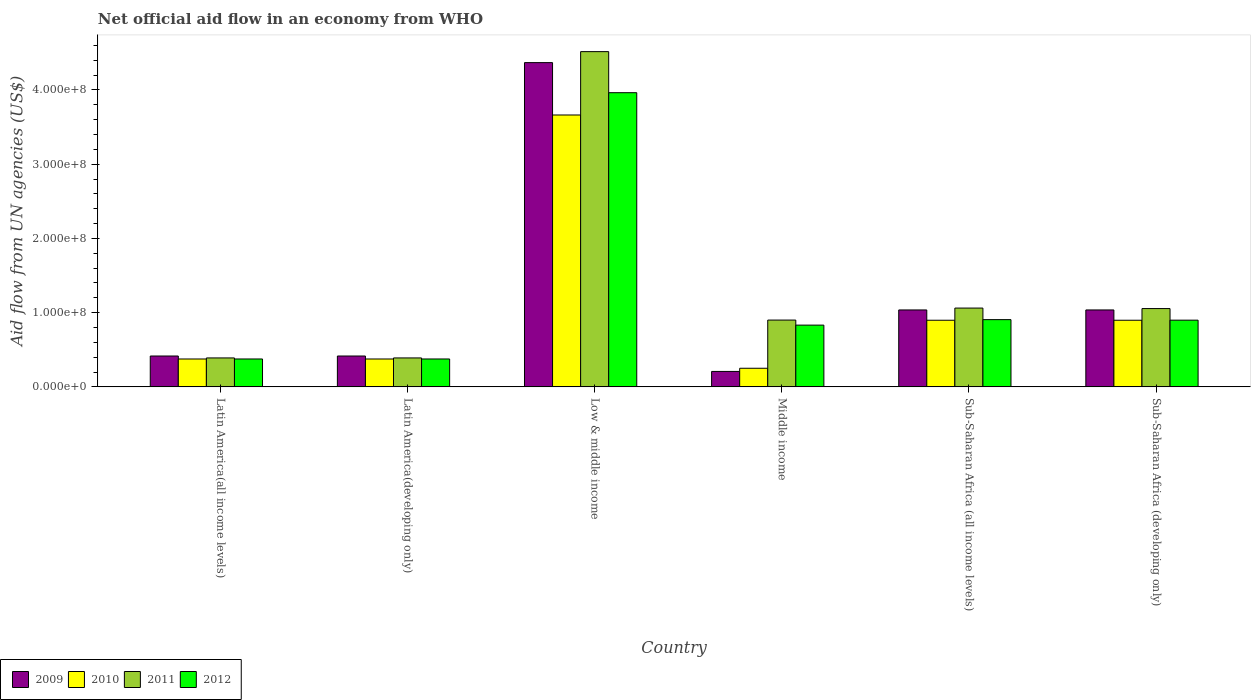How many different coloured bars are there?
Your answer should be very brief. 4. How many groups of bars are there?
Make the answer very short. 6. Are the number of bars per tick equal to the number of legend labels?
Keep it short and to the point. Yes. What is the label of the 2nd group of bars from the left?
Your response must be concise. Latin America(developing only). What is the net official aid flow in 2009 in Latin America(developing only)?
Your response must be concise. 4.16e+07. Across all countries, what is the maximum net official aid flow in 2011?
Your answer should be very brief. 4.52e+08. Across all countries, what is the minimum net official aid flow in 2009?
Your answer should be compact. 2.08e+07. In which country was the net official aid flow in 2009 maximum?
Provide a succinct answer. Low & middle income. In which country was the net official aid flow in 2009 minimum?
Provide a short and direct response. Middle income. What is the total net official aid flow in 2011 in the graph?
Make the answer very short. 8.31e+08. What is the difference between the net official aid flow in 2012 in Latin America(developing only) and that in Low & middle income?
Your answer should be very brief. -3.59e+08. What is the difference between the net official aid flow in 2012 in Low & middle income and the net official aid flow in 2011 in Sub-Saharan Africa (all income levels)?
Offer a terse response. 2.90e+08. What is the average net official aid flow in 2010 per country?
Offer a very short reply. 1.08e+08. What is the difference between the net official aid flow of/in 2009 and net official aid flow of/in 2010 in Sub-Saharan Africa (all income levels)?
Provide a short and direct response. 1.39e+07. What is the ratio of the net official aid flow in 2010 in Middle income to that in Sub-Saharan Africa (developing only)?
Ensure brevity in your answer.  0.28. Is the difference between the net official aid flow in 2009 in Latin America(developing only) and Sub-Saharan Africa (all income levels) greater than the difference between the net official aid flow in 2010 in Latin America(developing only) and Sub-Saharan Africa (all income levels)?
Offer a terse response. No. What is the difference between the highest and the second highest net official aid flow in 2012?
Ensure brevity in your answer.  3.06e+08. What is the difference between the highest and the lowest net official aid flow in 2012?
Keep it short and to the point. 3.59e+08. In how many countries, is the net official aid flow in 2010 greater than the average net official aid flow in 2010 taken over all countries?
Your response must be concise. 1. Is the sum of the net official aid flow in 2009 in Sub-Saharan Africa (all income levels) and Sub-Saharan Africa (developing only) greater than the maximum net official aid flow in 2010 across all countries?
Offer a very short reply. No. Is it the case that in every country, the sum of the net official aid flow in 2010 and net official aid flow in 2009 is greater than the sum of net official aid flow in 2011 and net official aid flow in 2012?
Offer a very short reply. No. What does the 1st bar from the right in Middle income represents?
Keep it short and to the point. 2012. Is it the case that in every country, the sum of the net official aid flow in 2012 and net official aid flow in 2009 is greater than the net official aid flow in 2011?
Keep it short and to the point. Yes. How many bars are there?
Give a very brief answer. 24. Are all the bars in the graph horizontal?
Your answer should be very brief. No. How many countries are there in the graph?
Offer a terse response. 6. What is the difference between two consecutive major ticks on the Y-axis?
Give a very brief answer. 1.00e+08. Does the graph contain any zero values?
Ensure brevity in your answer.  No. Does the graph contain grids?
Your answer should be compact. No. How are the legend labels stacked?
Your response must be concise. Horizontal. What is the title of the graph?
Ensure brevity in your answer.  Net official aid flow in an economy from WHO. Does "1966" appear as one of the legend labels in the graph?
Your answer should be very brief. No. What is the label or title of the Y-axis?
Offer a very short reply. Aid flow from UN agencies (US$). What is the Aid flow from UN agencies (US$) of 2009 in Latin America(all income levels)?
Your answer should be very brief. 4.16e+07. What is the Aid flow from UN agencies (US$) of 2010 in Latin America(all income levels)?
Provide a short and direct response. 3.76e+07. What is the Aid flow from UN agencies (US$) in 2011 in Latin America(all income levels)?
Offer a very short reply. 3.90e+07. What is the Aid flow from UN agencies (US$) of 2012 in Latin America(all income levels)?
Provide a succinct answer. 3.76e+07. What is the Aid flow from UN agencies (US$) of 2009 in Latin America(developing only)?
Your response must be concise. 4.16e+07. What is the Aid flow from UN agencies (US$) of 2010 in Latin America(developing only)?
Give a very brief answer. 3.76e+07. What is the Aid flow from UN agencies (US$) in 2011 in Latin America(developing only)?
Provide a short and direct response. 3.90e+07. What is the Aid flow from UN agencies (US$) of 2012 in Latin America(developing only)?
Offer a very short reply. 3.76e+07. What is the Aid flow from UN agencies (US$) in 2009 in Low & middle income?
Ensure brevity in your answer.  4.37e+08. What is the Aid flow from UN agencies (US$) of 2010 in Low & middle income?
Keep it short and to the point. 3.66e+08. What is the Aid flow from UN agencies (US$) in 2011 in Low & middle income?
Your response must be concise. 4.52e+08. What is the Aid flow from UN agencies (US$) in 2012 in Low & middle income?
Keep it short and to the point. 3.96e+08. What is the Aid flow from UN agencies (US$) of 2009 in Middle income?
Keep it short and to the point. 2.08e+07. What is the Aid flow from UN agencies (US$) of 2010 in Middle income?
Your answer should be compact. 2.51e+07. What is the Aid flow from UN agencies (US$) in 2011 in Middle income?
Offer a very short reply. 9.00e+07. What is the Aid flow from UN agencies (US$) of 2012 in Middle income?
Your answer should be compact. 8.32e+07. What is the Aid flow from UN agencies (US$) in 2009 in Sub-Saharan Africa (all income levels)?
Ensure brevity in your answer.  1.04e+08. What is the Aid flow from UN agencies (US$) of 2010 in Sub-Saharan Africa (all income levels)?
Your answer should be compact. 8.98e+07. What is the Aid flow from UN agencies (US$) of 2011 in Sub-Saharan Africa (all income levels)?
Offer a terse response. 1.06e+08. What is the Aid flow from UN agencies (US$) of 2012 in Sub-Saharan Africa (all income levels)?
Ensure brevity in your answer.  9.06e+07. What is the Aid flow from UN agencies (US$) in 2009 in Sub-Saharan Africa (developing only)?
Your answer should be compact. 1.04e+08. What is the Aid flow from UN agencies (US$) in 2010 in Sub-Saharan Africa (developing only)?
Your answer should be compact. 8.98e+07. What is the Aid flow from UN agencies (US$) of 2011 in Sub-Saharan Africa (developing only)?
Offer a terse response. 1.05e+08. What is the Aid flow from UN agencies (US$) of 2012 in Sub-Saharan Africa (developing only)?
Provide a succinct answer. 8.98e+07. Across all countries, what is the maximum Aid flow from UN agencies (US$) in 2009?
Ensure brevity in your answer.  4.37e+08. Across all countries, what is the maximum Aid flow from UN agencies (US$) of 2010?
Your answer should be very brief. 3.66e+08. Across all countries, what is the maximum Aid flow from UN agencies (US$) of 2011?
Make the answer very short. 4.52e+08. Across all countries, what is the maximum Aid flow from UN agencies (US$) of 2012?
Your answer should be very brief. 3.96e+08. Across all countries, what is the minimum Aid flow from UN agencies (US$) in 2009?
Give a very brief answer. 2.08e+07. Across all countries, what is the minimum Aid flow from UN agencies (US$) in 2010?
Provide a short and direct response. 2.51e+07. Across all countries, what is the minimum Aid flow from UN agencies (US$) in 2011?
Ensure brevity in your answer.  3.90e+07. Across all countries, what is the minimum Aid flow from UN agencies (US$) in 2012?
Make the answer very short. 3.76e+07. What is the total Aid flow from UN agencies (US$) in 2009 in the graph?
Provide a succinct answer. 7.48e+08. What is the total Aid flow from UN agencies (US$) in 2010 in the graph?
Ensure brevity in your answer.  6.46e+08. What is the total Aid flow from UN agencies (US$) of 2011 in the graph?
Keep it short and to the point. 8.31e+08. What is the total Aid flow from UN agencies (US$) in 2012 in the graph?
Offer a very short reply. 7.35e+08. What is the difference between the Aid flow from UN agencies (US$) of 2010 in Latin America(all income levels) and that in Latin America(developing only)?
Keep it short and to the point. 0. What is the difference between the Aid flow from UN agencies (US$) in 2011 in Latin America(all income levels) and that in Latin America(developing only)?
Keep it short and to the point. 0. What is the difference between the Aid flow from UN agencies (US$) in 2012 in Latin America(all income levels) and that in Latin America(developing only)?
Your response must be concise. 0. What is the difference between the Aid flow from UN agencies (US$) of 2009 in Latin America(all income levels) and that in Low & middle income?
Your answer should be very brief. -3.95e+08. What is the difference between the Aid flow from UN agencies (US$) of 2010 in Latin America(all income levels) and that in Low & middle income?
Your answer should be very brief. -3.29e+08. What is the difference between the Aid flow from UN agencies (US$) of 2011 in Latin America(all income levels) and that in Low & middle income?
Provide a succinct answer. -4.13e+08. What is the difference between the Aid flow from UN agencies (US$) of 2012 in Latin America(all income levels) and that in Low & middle income?
Provide a short and direct response. -3.59e+08. What is the difference between the Aid flow from UN agencies (US$) in 2009 in Latin America(all income levels) and that in Middle income?
Provide a succinct answer. 2.08e+07. What is the difference between the Aid flow from UN agencies (US$) in 2010 in Latin America(all income levels) and that in Middle income?
Offer a very short reply. 1.25e+07. What is the difference between the Aid flow from UN agencies (US$) in 2011 in Latin America(all income levels) and that in Middle income?
Make the answer very short. -5.10e+07. What is the difference between the Aid flow from UN agencies (US$) in 2012 in Latin America(all income levels) and that in Middle income?
Your answer should be very brief. -4.56e+07. What is the difference between the Aid flow from UN agencies (US$) of 2009 in Latin America(all income levels) and that in Sub-Saharan Africa (all income levels)?
Your answer should be very brief. -6.20e+07. What is the difference between the Aid flow from UN agencies (US$) in 2010 in Latin America(all income levels) and that in Sub-Saharan Africa (all income levels)?
Provide a succinct answer. -5.22e+07. What is the difference between the Aid flow from UN agencies (US$) in 2011 in Latin America(all income levels) and that in Sub-Saharan Africa (all income levels)?
Your answer should be very brief. -6.72e+07. What is the difference between the Aid flow from UN agencies (US$) of 2012 in Latin America(all income levels) and that in Sub-Saharan Africa (all income levels)?
Give a very brief answer. -5.30e+07. What is the difference between the Aid flow from UN agencies (US$) of 2009 in Latin America(all income levels) and that in Sub-Saharan Africa (developing only)?
Your response must be concise. -6.20e+07. What is the difference between the Aid flow from UN agencies (US$) in 2010 in Latin America(all income levels) and that in Sub-Saharan Africa (developing only)?
Provide a short and direct response. -5.22e+07. What is the difference between the Aid flow from UN agencies (US$) in 2011 in Latin America(all income levels) and that in Sub-Saharan Africa (developing only)?
Offer a very short reply. -6.65e+07. What is the difference between the Aid flow from UN agencies (US$) of 2012 in Latin America(all income levels) and that in Sub-Saharan Africa (developing only)?
Ensure brevity in your answer.  -5.23e+07. What is the difference between the Aid flow from UN agencies (US$) of 2009 in Latin America(developing only) and that in Low & middle income?
Your response must be concise. -3.95e+08. What is the difference between the Aid flow from UN agencies (US$) in 2010 in Latin America(developing only) and that in Low & middle income?
Your response must be concise. -3.29e+08. What is the difference between the Aid flow from UN agencies (US$) of 2011 in Latin America(developing only) and that in Low & middle income?
Provide a succinct answer. -4.13e+08. What is the difference between the Aid flow from UN agencies (US$) in 2012 in Latin America(developing only) and that in Low & middle income?
Offer a terse response. -3.59e+08. What is the difference between the Aid flow from UN agencies (US$) in 2009 in Latin America(developing only) and that in Middle income?
Offer a terse response. 2.08e+07. What is the difference between the Aid flow from UN agencies (US$) of 2010 in Latin America(developing only) and that in Middle income?
Offer a very short reply. 1.25e+07. What is the difference between the Aid flow from UN agencies (US$) in 2011 in Latin America(developing only) and that in Middle income?
Offer a terse response. -5.10e+07. What is the difference between the Aid flow from UN agencies (US$) in 2012 in Latin America(developing only) and that in Middle income?
Offer a very short reply. -4.56e+07. What is the difference between the Aid flow from UN agencies (US$) in 2009 in Latin America(developing only) and that in Sub-Saharan Africa (all income levels)?
Offer a very short reply. -6.20e+07. What is the difference between the Aid flow from UN agencies (US$) in 2010 in Latin America(developing only) and that in Sub-Saharan Africa (all income levels)?
Keep it short and to the point. -5.22e+07. What is the difference between the Aid flow from UN agencies (US$) of 2011 in Latin America(developing only) and that in Sub-Saharan Africa (all income levels)?
Keep it short and to the point. -6.72e+07. What is the difference between the Aid flow from UN agencies (US$) in 2012 in Latin America(developing only) and that in Sub-Saharan Africa (all income levels)?
Make the answer very short. -5.30e+07. What is the difference between the Aid flow from UN agencies (US$) in 2009 in Latin America(developing only) and that in Sub-Saharan Africa (developing only)?
Provide a succinct answer. -6.20e+07. What is the difference between the Aid flow from UN agencies (US$) of 2010 in Latin America(developing only) and that in Sub-Saharan Africa (developing only)?
Offer a terse response. -5.22e+07. What is the difference between the Aid flow from UN agencies (US$) in 2011 in Latin America(developing only) and that in Sub-Saharan Africa (developing only)?
Make the answer very short. -6.65e+07. What is the difference between the Aid flow from UN agencies (US$) in 2012 in Latin America(developing only) and that in Sub-Saharan Africa (developing only)?
Your response must be concise. -5.23e+07. What is the difference between the Aid flow from UN agencies (US$) of 2009 in Low & middle income and that in Middle income?
Provide a succinct answer. 4.16e+08. What is the difference between the Aid flow from UN agencies (US$) of 2010 in Low & middle income and that in Middle income?
Give a very brief answer. 3.41e+08. What is the difference between the Aid flow from UN agencies (US$) in 2011 in Low & middle income and that in Middle income?
Your response must be concise. 3.62e+08. What is the difference between the Aid flow from UN agencies (US$) of 2012 in Low & middle income and that in Middle income?
Offer a very short reply. 3.13e+08. What is the difference between the Aid flow from UN agencies (US$) of 2009 in Low & middle income and that in Sub-Saharan Africa (all income levels)?
Keep it short and to the point. 3.33e+08. What is the difference between the Aid flow from UN agencies (US$) of 2010 in Low & middle income and that in Sub-Saharan Africa (all income levels)?
Make the answer very short. 2.76e+08. What is the difference between the Aid flow from UN agencies (US$) in 2011 in Low & middle income and that in Sub-Saharan Africa (all income levels)?
Provide a succinct answer. 3.45e+08. What is the difference between the Aid flow from UN agencies (US$) of 2012 in Low & middle income and that in Sub-Saharan Africa (all income levels)?
Provide a succinct answer. 3.06e+08. What is the difference between the Aid flow from UN agencies (US$) of 2009 in Low & middle income and that in Sub-Saharan Africa (developing only)?
Offer a very short reply. 3.33e+08. What is the difference between the Aid flow from UN agencies (US$) in 2010 in Low & middle income and that in Sub-Saharan Africa (developing only)?
Ensure brevity in your answer.  2.76e+08. What is the difference between the Aid flow from UN agencies (US$) in 2011 in Low & middle income and that in Sub-Saharan Africa (developing only)?
Ensure brevity in your answer.  3.46e+08. What is the difference between the Aid flow from UN agencies (US$) in 2012 in Low & middle income and that in Sub-Saharan Africa (developing only)?
Provide a short and direct response. 3.06e+08. What is the difference between the Aid flow from UN agencies (US$) of 2009 in Middle income and that in Sub-Saharan Africa (all income levels)?
Your response must be concise. -8.28e+07. What is the difference between the Aid flow from UN agencies (US$) in 2010 in Middle income and that in Sub-Saharan Africa (all income levels)?
Provide a short and direct response. -6.47e+07. What is the difference between the Aid flow from UN agencies (US$) of 2011 in Middle income and that in Sub-Saharan Africa (all income levels)?
Your response must be concise. -1.62e+07. What is the difference between the Aid flow from UN agencies (US$) in 2012 in Middle income and that in Sub-Saharan Africa (all income levels)?
Give a very brief answer. -7.39e+06. What is the difference between the Aid flow from UN agencies (US$) of 2009 in Middle income and that in Sub-Saharan Africa (developing only)?
Your answer should be compact. -8.28e+07. What is the difference between the Aid flow from UN agencies (US$) in 2010 in Middle income and that in Sub-Saharan Africa (developing only)?
Offer a very short reply. -6.47e+07. What is the difference between the Aid flow from UN agencies (US$) in 2011 in Middle income and that in Sub-Saharan Africa (developing only)?
Provide a short and direct response. -1.55e+07. What is the difference between the Aid flow from UN agencies (US$) of 2012 in Middle income and that in Sub-Saharan Africa (developing only)?
Provide a succinct answer. -6.67e+06. What is the difference between the Aid flow from UN agencies (US$) of 2010 in Sub-Saharan Africa (all income levels) and that in Sub-Saharan Africa (developing only)?
Keep it short and to the point. 0. What is the difference between the Aid flow from UN agencies (US$) in 2011 in Sub-Saharan Africa (all income levels) and that in Sub-Saharan Africa (developing only)?
Ensure brevity in your answer.  6.70e+05. What is the difference between the Aid flow from UN agencies (US$) in 2012 in Sub-Saharan Africa (all income levels) and that in Sub-Saharan Africa (developing only)?
Provide a short and direct response. 7.20e+05. What is the difference between the Aid flow from UN agencies (US$) in 2009 in Latin America(all income levels) and the Aid flow from UN agencies (US$) in 2010 in Latin America(developing only)?
Keep it short and to the point. 4.01e+06. What is the difference between the Aid flow from UN agencies (US$) of 2009 in Latin America(all income levels) and the Aid flow from UN agencies (US$) of 2011 in Latin America(developing only)?
Provide a short and direct response. 2.59e+06. What is the difference between the Aid flow from UN agencies (US$) in 2009 in Latin America(all income levels) and the Aid flow from UN agencies (US$) in 2012 in Latin America(developing only)?
Ensure brevity in your answer.  3.99e+06. What is the difference between the Aid flow from UN agencies (US$) in 2010 in Latin America(all income levels) and the Aid flow from UN agencies (US$) in 2011 in Latin America(developing only)?
Give a very brief answer. -1.42e+06. What is the difference between the Aid flow from UN agencies (US$) in 2011 in Latin America(all income levels) and the Aid flow from UN agencies (US$) in 2012 in Latin America(developing only)?
Provide a short and direct response. 1.40e+06. What is the difference between the Aid flow from UN agencies (US$) in 2009 in Latin America(all income levels) and the Aid flow from UN agencies (US$) in 2010 in Low & middle income?
Keep it short and to the point. -3.25e+08. What is the difference between the Aid flow from UN agencies (US$) in 2009 in Latin America(all income levels) and the Aid flow from UN agencies (US$) in 2011 in Low & middle income?
Offer a terse response. -4.10e+08. What is the difference between the Aid flow from UN agencies (US$) in 2009 in Latin America(all income levels) and the Aid flow from UN agencies (US$) in 2012 in Low & middle income?
Your answer should be compact. -3.55e+08. What is the difference between the Aid flow from UN agencies (US$) in 2010 in Latin America(all income levels) and the Aid flow from UN agencies (US$) in 2011 in Low & middle income?
Keep it short and to the point. -4.14e+08. What is the difference between the Aid flow from UN agencies (US$) in 2010 in Latin America(all income levels) and the Aid flow from UN agencies (US$) in 2012 in Low & middle income?
Your answer should be compact. -3.59e+08. What is the difference between the Aid flow from UN agencies (US$) in 2011 in Latin America(all income levels) and the Aid flow from UN agencies (US$) in 2012 in Low & middle income?
Ensure brevity in your answer.  -3.57e+08. What is the difference between the Aid flow from UN agencies (US$) in 2009 in Latin America(all income levels) and the Aid flow from UN agencies (US$) in 2010 in Middle income?
Ensure brevity in your answer.  1.65e+07. What is the difference between the Aid flow from UN agencies (US$) in 2009 in Latin America(all income levels) and the Aid flow from UN agencies (US$) in 2011 in Middle income?
Ensure brevity in your answer.  -4.84e+07. What is the difference between the Aid flow from UN agencies (US$) in 2009 in Latin America(all income levels) and the Aid flow from UN agencies (US$) in 2012 in Middle income?
Your answer should be compact. -4.16e+07. What is the difference between the Aid flow from UN agencies (US$) in 2010 in Latin America(all income levels) and the Aid flow from UN agencies (US$) in 2011 in Middle income?
Offer a very short reply. -5.24e+07. What is the difference between the Aid flow from UN agencies (US$) of 2010 in Latin America(all income levels) and the Aid flow from UN agencies (US$) of 2012 in Middle income?
Your answer should be compact. -4.56e+07. What is the difference between the Aid flow from UN agencies (US$) of 2011 in Latin America(all income levels) and the Aid flow from UN agencies (US$) of 2012 in Middle income?
Ensure brevity in your answer.  -4.42e+07. What is the difference between the Aid flow from UN agencies (US$) of 2009 in Latin America(all income levels) and the Aid flow from UN agencies (US$) of 2010 in Sub-Saharan Africa (all income levels)?
Your answer should be very brief. -4.82e+07. What is the difference between the Aid flow from UN agencies (US$) of 2009 in Latin America(all income levels) and the Aid flow from UN agencies (US$) of 2011 in Sub-Saharan Africa (all income levels)?
Offer a terse response. -6.46e+07. What is the difference between the Aid flow from UN agencies (US$) of 2009 in Latin America(all income levels) and the Aid flow from UN agencies (US$) of 2012 in Sub-Saharan Africa (all income levels)?
Offer a very short reply. -4.90e+07. What is the difference between the Aid flow from UN agencies (US$) in 2010 in Latin America(all income levels) and the Aid flow from UN agencies (US$) in 2011 in Sub-Saharan Africa (all income levels)?
Provide a short and direct response. -6.86e+07. What is the difference between the Aid flow from UN agencies (US$) of 2010 in Latin America(all income levels) and the Aid flow from UN agencies (US$) of 2012 in Sub-Saharan Africa (all income levels)?
Offer a terse response. -5.30e+07. What is the difference between the Aid flow from UN agencies (US$) of 2011 in Latin America(all income levels) and the Aid flow from UN agencies (US$) of 2012 in Sub-Saharan Africa (all income levels)?
Keep it short and to the point. -5.16e+07. What is the difference between the Aid flow from UN agencies (US$) in 2009 in Latin America(all income levels) and the Aid flow from UN agencies (US$) in 2010 in Sub-Saharan Africa (developing only)?
Your answer should be very brief. -4.82e+07. What is the difference between the Aid flow from UN agencies (US$) of 2009 in Latin America(all income levels) and the Aid flow from UN agencies (US$) of 2011 in Sub-Saharan Africa (developing only)?
Offer a terse response. -6.39e+07. What is the difference between the Aid flow from UN agencies (US$) in 2009 in Latin America(all income levels) and the Aid flow from UN agencies (US$) in 2012 in Sub-Saharan Africa (developing only)?
Ensure brevity in your answer.  -4.83e+07. What is the difference between the Aid flow from UN agencies (US$) in 2010 in Latin America(all income levels) and the Aid flow from UN agencies (US$) in 2011 in Sub-Saharan Africa (developing only)?
Your answer should be compact. -6.79e+07. What is the difference between the Aid flow from UN agencies (US$) in 2010 in Latin America(all income levels) and the Aid flow from UN agencies (US$) in 2012 in Sub-Saharan Africa (developing only)?
Keep it short and to the point. -5.23e+07. What is the difference between the Aid flow from UN agencies (US$) in 2011 in Latin America(all income levels) and the Aid flow from UN agencies (US$) in 2012 in Sub-Saharan Africa (developing only)?
Keep it short and to the point. -5.09e+07. What is the difference between the Aid flow from UN agencies (US$) of 2009 in Latin America(developing only) and the Aid flow from UN agencies (US$) of 2010 in Low & middle income?
Your answer should be very brief. -3.25e+08. What is the difference between the Aid flow from UN agencies (US$) in 2009 in Latin America(developing only) and the Aid flow from UN agencies (US$) in 2011 in Low & middle income?
Your answer should be very brief. -4.10e+08. What is the difference between the Aid flow from UN agencies (US$) of 2009 in Latin America(developing only) and the Aid flow from UN agencies (US$) of 2012 in Low & middle income?
Provide a succinct answer. -3.55e+08. What is the difference between the Aid flow from UN agencies (US$) in 2010 in Latin America(developing only) and the Aid flow from UN agencies (US$) in 2011 in Low & middle income?
Ensure brevity in your answer.  -4.14e+08. What is the difference between the Aid flow from UN agencies (US$) in 2010 in Latin America(developing only) and the Aid flow from UN agencies (US$) in 2012 in Low & middle income?
Provide a short and direct response. -3.59e+08. What is the difference between the Aid flow from UN agencies (US$) in 2011 in Latin America(developing only) and the Aid flow from UN agencies (US$) in 2012 in Low & middle income?
Offer a very short reply. -3.57e+08. What is the difference between the Aid flow from UN agencies (US$) of 2009 in Latin America(developing only) and the Aid flow from UN agencies (US$) of 2010 in Middle income?
Give a very brief answer. 1.65e+07. What is the difference between the Aid flow from UN agencies (US$) in 2009 in Latin America(developing only) and the Aid flow from UN agencies (US$) in 2011 in Middle income?
Provide a short and direct response. -4.84e+07. What is the difference between the Aid flow from UN agencies (US$) of 2009 in Latin America(developing only) and the Aid flow from UN agencies (US$) of 2012 in Middle income?
Your answer should be compact. -4.16e+07. What is the difference between the Aid flow from UN agencies (US$) in 2010 in Latin America(developing only) and the Aid flow from UN agencies (US$) in 2011 in Middle income?
Offer a terse response. -5.24e+07. What is the difference between the Aid flow from UN agencies (US$) of 2010 in Latin America(developing only) and the Aid flow from UN agencies (US$) of 2012 in Middle income?
Provide a succinct answer. -4.56e+07. What is the difference between the Aid flow from UN agencies (US$) in 2011 in Latin America(developing only) and the Aid flow from UN agencies (US$) in 2012 in Middle income?
Your answer should be compact. -4.42e+07. What is the difference between the Aid flow from UN agencies (US$) in 2009 in Latin America(developing only) and the Aid flow from UN agencies (US$) in 2010 in Sub-Saharan Africa (all income levels)?
Give a very brief answer. -4.82e+07. What is the difference between the Aid flow from UN agencies (US$) of 2009 in Latin America(developing only) and the Aid flow from UN agencies (US$) of 2011 in Sub-Saharan Africa (all income levels)?
Your response must be concise. -6.46e+07. What is the difference between the Aid flow from UN agencies (US$) of 2009 in Latin America(developing only) and the Aid flow from UN agencies (US$) of 2012 in Sub-Saharan Africa (all income levels)?
Offer a very short reply. -4.90e+07. What is the difference between the Aid flow from UN agencies (US$) in 2010 in Latin America(developing only) and the Aid flow from UN agencies (US$) in 2011 in Sub-Saharan Africa (all income levels)?
Your answer should be very brief. -6.86e+07. What is the difference between the Aid flow from UN agencies (US$) of 2010 in Latin America(developing only) and the Aid flow from UN agencies (US$) of 2012 in Sub-Saharan Africa (all income levels)?
Give a very brief answer. -5.30e+07. What is the difference between the Aid flow from UN agencies (US$) in 2011 in Latin America(developing only) and the Aid flow from UN agencies (US$) in 2012 in Sub-Saharan Africa (all income levels)?
Give a very brief answer. -5.16e+07. What is the difference between the Aid flow from UN agencies (US$) of 2009 in Latin America(developing only) and the Aid flow from UN agencies (US$) of 2010 in Sub-Saharan Africa (developing only)?
Offer a very short reply. -4.82e+07. What is the difference between the Aid flow from UN agencies (US$) in 2009 in Latin America(developing only) and the Aid flow from UN agencies (US$) in 2011 in Sub-Saharan Africa (developing only)?
Make the answer very short. -6.39e+07. What is the difference between the Aid flow from UN agencies (US$) of 2009 in Latin America(developing only) and the Aid flow from UN agencies (US$) of 2012 in Sub-Saharan Africa (developing only)?
Your response must be concise. -4.83e+07. What is the difference between the Aid flow from UN agencies (US$) in 2010 in Latin America(developing only) and the Aid flow from UN agencies (US$) in 2011 in Sub-Saharan Africa (developing only)?
Offer a terse response. -6.79e+07. What is the difference between the Aid flow from UN agencies (US$) in 2010 in Latin America(developing only) and the Aid flow from UN agencies (US$) in 2012 in Sub-Saharan Africa (developing only)?
Offer a terse response. -5.23e+07. What is the difference between the Aid flow from UN agencies (US$) of 2011 in Latin America(developing only) and the Aid flow from UN agencies (US$) of 2012 in Sub-Saharan Africa (developing only)?
Your answer should be compact. -5.09e+07. What is the difference between the Aid flow from UN agencies (US$) of 2009 in Low & middle income and the Aid flow from UN agencies (US$) of 2010 in Middle income?
Make the answer very short. 4.12e+08. What is the difference between the Aid flow from UN agencies (US$) of 2009 in Low & middle income and the Aid flow from UN agencies (US$) of 2011 in Middle income?
Provide a short and direct response. 3.47e+08. What is the difference between the Aid flow from UN agencies (US$) in 2009 in Low & middle income and the Aid flow from UN agencies (US$) in 2012 in Middle income?
Keep it short and to the point. 3.54e+08. What is the difference between the Aid flow from UN agencies (US$) of 2010 in Low & middle income and the Aid flow from UN agencies (US$) of 2011 in Middle income?
Your answer should be very brief. 2.76e+08. What is the difference between the Aid flow from UN agencies (US$) of 2010 in Low & middle income and the Aid flow from UN agencies (US$) of 2012 in Middle income?
Offer a very short reply. 2.83e+08. What is the difference between the Aid flow from UN agencies (US$) in 2011 in Low & middle income and the Aid flow from UN agencies (US$) in 2012 in Middle income?
Make the answer very short. 3.68e+08. What is the difference between the Aid flow from UN agencies (US$) of 2009 in Low & middle income and the Aid flow from UN agencies (US$) of 2010 in Sub-Saharan Africa (all income levels)?
Give a very brief answer. 3.47e+08. What is the difference between the Aid flow from UN agencies (US$) in 2009 in Low & middle income and the Aid flow from UN agencies (US$) in 2011 in Sub-Saharan Africa (all income levels)?
Your response must be concise. 3.31e+08. What is the difference between the Aid flow from UN agencies (US$) of 2009 in Low & middle income and the Aid flow from UN agencies (US$) of 2012 in Sub-Saharan Africa (all income levels)?
Provide a succinct answer. 3.46e+08. What is the difference between the Aid flow from UN agencies (US$) in 2010 in Low & middle income and the Aid flow from UN agencies (US$) in 2011 in Sub-Saharan Africa (all income levels)?
Give a very brief answer. 2.60e+08. What is the difference between the Aid flow from UN agencies (US$) in 2010 in Low & middle income and the Aid flow from UN agencies (US$) in 2012 in Sub-Saharan Africa (all income levels)?
Offer a very short reply. 2.76e+08. What is the difference between the Aid flow from UN agencies (US$) in 2011 in Low & middle income and the Aid flow from UN agencies (US$) in 2012 in Sub-Saharan Africa (all income levels)?
Make the answer very short. 3.61e+08. What is the difference between the Aid flow from UN agencies (US$) in 2009 in Low & middle income and the Aid flow from UN agencies (US$) in 2010 in Sub-Saharan Africa (developing only)?
Offer a terse response. 3.47e+08. What is the difference between the Aid flow from UN agencies (US$) of 2009 in Low & middle income and the Aid flow from UN agencies (US$) of 2011 in Sub-Saharan Africa (developing only)?
Ensure brevity in your answer.  3.31e+08. What is the difference between the Aid flow from UN agencies (US$) in 2009 in Low & middle income and the Aid flow from UN agencies (US$) in 2012 in Sub-Saharan Africa (developing only)?
Make the answer very short. 3.47e+08. What is the difference between the Aid flow from UN agencies (US$) of 2010 in Low & middle income and the Aid flow from UN agencies (US$) of 2011 in Sub-Saharan Africa (developing only)?
Give a very brief answer. 2.61e+08. What is the difference between the Aid flow from UN agencies (US$) in 2010 in Low & middle income and the Aid flow from UN agencies (US$) in 2012 in Sub-Saharan Africa (developing only)?
Your response must be concise. 2.76e+08. What is the difference between the Aid flow from UN agencies (US$) of 2011 in Low & middle income and the Aid flow from UN agencies (US$) of 2012 in Sub-Saharan Africa (developing only)?
Your answer should be very brief. 3.62e+08. What is the difference between the Aid flow from UN agencies (US$) of 2009 in Middle income and the Aid flow from UN agencies (US$) of 2010 in Sub-Saharan Africa (all income levels)?
Your response must be concise. -6.90e+07. What is the difference between the Aid flow from UN agencies (US$) in 2009 in Middle income and the Aid flow from UN agencies (US$) in 2011 in Sub-Saharan Africa (all income levels)?
Make the answer very short. -8.54e+07. What is the difference between the Aid flow from UN agencies (US$) in 2009 in Middle income and the Aid flow from UN agencies (US$) in 2012 in Sub-Saharan Africa (all income levels)?
Provide a succinct answer. -6.98e+07. What is the difference between the Aid flow from UN agencies (US$) of 2010 in Middle income and the Aid flow from UN agencies (US$) of 2011 in Sub-Saharan Africa (all income levels)?
Offer a very short reply. -8.11e+07. What is the difference between the Aid flow from UN agencies (US$) of 2010 in Middle income and the Aid flow from UN agencies (US$) of 2012 in Sub-Saharan Africa (all income levels)?
Your answer should be compact. -6.55e+07. What is the difference between the Aid flow from UN agencies (US$) in 2011 in Middle income and the Aid flow from UN agencies (US$) in 2012 in Sub-Saharan Africa (all income levels)?
Make the answer very short. -5.90e+05. What is the difference between the Aid flow from UN agencies (US$) in 2009 in Middle income and the Aid flow from UN agencies (US$) in 2010 in Sub-Saharan Africa (developing only)?
Offer a very short reply. -6.90e+07. What is the difference between the Aid flow from UN agencies (US$) in 2009 in Middle income and the Aid flow from UN agencies (US$) in 2011 in Sub-Saharan Africa (developing only)?
Provide a succinct answer. -8.47e+07. What is the difference between the Aid flow from UN agencies (US$) of 2009 in Middle income and the Aid flow from UN agencies (US$) of 2012 in Sub-Saharan Africa (developing only)?
Your answer should be very brief. -6.90e+07. What is the difference between the Aid flow from UN agencies (US$) in 2010 in Middle income and the Aid flow from UN agencies (US$) in 2011 in Sub-Saharan Africa (developing only)?
Your response must be concise. -8.04e+07. What is the difference between the Aid flow from UN agencies (US$) of 2010 in Middle income and the Aid flow from UN agencies (US$) of 2012 in Sub-Saharan Africa (developing only)?
Offer a terse response. -6.48e+07. What is the difference between the Aid flow from UN agencies (US$) in 2009 in Sub-Saharan Africa (all income levels) and the Aid flow from UN agencies (US$) in 2010 in Sub-Saharan Africa (developing only)?
Make the answer very short. 1.39e+07. What is the difference between the Aid flow from UN agencies (US$) in 2009 in Sub-Saharan Africa (all income levels) and the Aid flow from UN agencies (US$) in 2011 in Sub-Saharan Africa (developing only)?
Keep it short and to the point. -1.86e+06. What is the difference between the Aid flow from UN agencies (US$) in 2009 in Sub-Saharan Africa (all income levels) and the Aid flow from UN agencies (US$) in 2012 in Sub-Saharan Africa (developing only)?
Offer a terse response. 1.38e+07. What is the difference between the Aid flow from UN agencies (US$) in 2010 in Sub-Saharan Africa (all income levels) and the Aid flow from UN agencies (US$) in 2011 in Sub-Saharan Africa (developing only)?
Give a very brief answer. -1.57e+07. What is the difference between the Aid flow from UN agencies (US$) in 2011 in Sub-Saharan Africa (all income levels) and the Aid flow from UN agencies (US$) in 2012 in Sub-Saharan Africa (developing only)?
Offer a very short reply. 1.63e+07. What is the average Aid flow from UN agencies (US$) of 2009 per country?
Ensure brevity in your answer.  1.25e+08. What is the average Aid flow from UN agencies (US$) of 2010 per country?
Your response must be concise. 1.08e+08. What is the average Aid flow from UN agencies (US$) of 2011 per country?
Give a very brief answer. 1.39e+08. What is the average Aid flow from UN agencies (US$) in 2012 per country?
Your response must be concise. 1.23e+08. What is the difference between the Aid flow from UN agencies (US$) of 2009 and Aid flow from UN agencies (US$) of 2010 in Latin America(all income levels)?
Ensure brevity in your answer.  4.01e+06. What is the difference between the Aid flow from UN agencies (US$) in 2009 and Aid flow from UN agencies (US$) in 2011 in Latin America(all income levels)?
Give a very brief answer. 2.59e+06. What is the difference between the Aid flow from UN agencies (US$) of 2009 and Aid flow from UN agencies (US$) of 2012 in Latin America(all income levels)?
Make the answer very short. 3.99e+06. What is the difference between the Aid flow from UN agencies (US$) of 2010 and Aid flow from UN agencies (US$) of 2011 in Latin America(all income levels)?
Keep it short and to the point. -1.42e+06. What is the difference between the Aid flow from UN agencies (US$) of 2010 and Aid flow from UN agencies (US$) of 2012 in Latin America(all income levels)?
Offer a terse response. -2.00e+04. What is the difference between the Aid flow from UN agencies (US$) of 2011 and Aid flow from UN agencies (US$) of 2012 in Latin America(all income levels)?
Provide a succinct answer. 1.40e+06. What is the difference between the Aid flow from UN agencies (US$) in 2009 and Aid flow from UN agencies (US$) in 2010 in Latin America(developing only)?
Offer a very short reply. 4.01e+06. What is the difference between the Aid flow from UN agencies (US$) in 2009 and Aid flow from UN agencies (US$) in 2011 in Latin America(developing only)?
Give a very brief answer. 2.59e+06. What is the difference between the Aid flow from UN agencies (US$) in 2009 and Aid flow from UN agencies (US$) in 2012 in Latin America(developing only)?
Offer a terse response. 3.99e+06. What is the difference between the Aid flow from UN agencies (US$) of 2010 and Aid flow from UN agencies (US$) of 2011 in Latin America(developing only)?
Provide a short and direct response. -1.42e+06. What is the difference between the Aid flow from UN agencies (US$) of 2011 and Aid flow from UN agencies (US$) of 2012 in Latin America(developing only)?
Offer a very short reply. 1.40e+06. What is the difference between the Aid flow from UN agencies (US$) in 2009 and Aid flow from UN agencies (US$) in 2010 in Low & middle income?
Offer a terse response. 7.06e+07. What is the difference between the Aid flow from UN agencies (US$) in 2009 and Aid flow from UN agencies (US$) in 2011 in Low & middle income?
Your answer should be compact. -1.48e+07. What is the difference between the Aid flow from UN agencies (US$) of 2009 and Aid flow from UN agencies (US$) of 2012 in Low & middle income?
Your answer should be very brief. 4.05e+07. What is the difference between the Aid flow from UN agencies (US$) of 2010 and Aid flow from UN agencies (US$) of 2011 in Low & middle income?
Make the answer very short. -8.54e+07. What is the difference between the Aid flow from UN agencies (US$) in 2010 and Aid flow from UN agencies (US$) in 2012 in Low & middle income?
Offer a terse response. -3.00e+07. What is the difference between the Aid flow from UN agencies (US$) of 2011 and Aid flow from UN agencies (US$) of 2012 in Low & middle income?
Offer a terse response. 5.53e+07. What is the difference between the Aid flow from UN agencies (US$) of 2009 and Aid flow from UN agencies (US$) of 2010 in Middle income?
Offer a very short reply. -4.27e+06. What is the difference between the Aid flow from UN agencies (US$) of 2009 and Aid flow from UN agencies (US$) of 2011 in Middle income?
Keep it short and to the point. -6.92e+07. What is the difference between the Aid flow from UN agencies (US$) of 2009 and Aid flow from UN agencies (US$) of 2012 in Middle income?
Make the answer very short. -6.24e+07. What is the difference between the Aid flow from UN agencies (US$) in 2010 and Aid flow from UN agencies (US$) in 2011 in Middle income?
Your answer should be compact. -6.49e+07. What is the difference between the Aid flow from UN agencies (US$) in 2010 and Aid flow from UN agencies (US$) in 2012 in Middle income?
Provide a succinct answer. -5.81e+07. What is the difference between the Aid flow from UN agencies (US$) in 2011 and Aid flow from UN agencies (US$) in 2012 in Middle income?
Give a very brief answer. 6.80e+06. What is the difference between the Aid flow from UN agencies (US$) of 2009 and Aid flow from UN agencies (US$) of 2010 in Sub-Saharan Africa (all income levels)?
Provide a short and direct response. 1.39e+07. What is the difference between the Aid flow from UN agencies (US$) of 2009 and Aid flow from UN agencies (US$) of 2011 in Sub-Saharan Africa (all income levels)?
Your answer should be compact. -2.53e+06. What is the difference between the Aid flow from UN agencies (US$) of 2009 and Aid flow from UN agencies (US$) of 2012 in Sub-Saharan Africa (all income levels)?
Provide a succinct answer. 1.30e+07. What is the difference between the Aid flow from UN agencies (US$) in 2010 and Aid flow from UN agencies (US$) in 2011 in Sub-Saharan Africa (all income levels)?
Your answer should be very brief. -1.64e+07. What is the difference between the Aid flow from UN agencies (US$) of 2010 and Aid flow from UN agencies (US$) of 2012 in Sub-Saharan Africa (all income levels)?
Provide a short and direct response. -8.10e+05. What is the difference between the Aid flow from UN agencies (US$) of 2011 and Aid flow from UN agencies (US$) of 2012 in Sub-Saharan Africa (all income levels)?
Your response must be concise. 1.56e+07. What is the difference between the Aid flow from UN agencies (US$) of 2009 and Aid flow from UN agencies (US$) of 2010 in Sub-Saharan Africa (developing only)?
Provide a succinct answer. 1.39e+07. What is the difference between the Aid flow from UN agencies (US$) of 2009 and Aid flow from UN agencies (US$) of 2011 in Sub-Saharan Africa (developing only)?
Make the answer very short. -1.86e+06. What is the difference between the Aid flow from UN agencies (US$) in 2009 and Aid flow from UN agencies (US$) in 2012 in Sub-Saharan Africa (developing only)?
Your answer should be very brief. 1.38e+07. What is the difference between the Aid flow from UN agencies (US$) of 2010 and Aid flow from UN agencies (US$) of 2011 in Sub-Saharan Africa (developing only)?
Your response must be concise. -1.57e+07. What is the difference between the Aid flow from UN agencies (US$) of 2011 and Aid flow from UN agencies (US$) of 2012 in Sub-Saharan Africa (developing only)?
Provide a succinct answer. 1.56e+07. What is the ratio of the Aid flow from UN agencies (US$) in 2009 in Latin America(all income levels) to that in Latin America(developing only)?
Ensure brevity in your answer.  1. What is the ratio of the Aid flow from UN agencies (US$) of 2010 in Latin America(all income levels) to that in Latin America(developing only)?
Give a very brief answer. 1. What is the ratio of the Aid flow from UN agencies (US$) of 2011 in Latin America(all income levels) to that in Latin America(developing only)?
Your answer should be very brief. 1. What is the ratio of the Aid flow from UN agencies (US$) of 2009 in Latin America(all income levels) to that in Low & middle income?
Offer a very short reply. 0.1. What is the ratio of the Aid flow from UN agencies (US$) in 2010 in Latin America(all income levels) to that in Low & middle income?
Offer a very short reply. 0.1. What is the ratio of the Aid flow from UN agencies (US$) of 2011 in Latin America(all income levels) to that in Low & middle income?
Provide a short and direct response. 0.09. What is the ratio of the Aid flow from UN agencies (US$) of 2012 in Latin America(all income levels) to that in Low & middle income?
Make the answer very short. 0.09. What is the ratio of the Aid flow from UN agencies (US$) of 2009 in Latin America(all income levels) to that in Middle income?
Provide a short and direct response. 2. What is the ratio of the Aid flow from UN agencies (US$) of 2010 in Latin America(all income levels) to that in Middle income?
Offer a terse response. 1.5. What is the ratio of the Aid flow from UN agencies (US$) of 2011 in Latin America(all income levels) to that in Middle income?
Make the answer very short. 0.43. What is the ratio of the Aid flow from UN agencies (US$) of 2012 in Latin America(all income levels) to that in Middle income?
Ensure brevity in your answer.  0.45. What is the ratio of the Aid flow from UN agencies (US$) in 2009 in Latin America(all income levels) to that in Sub-Saharan Africa (all income levels)?
Provide a succinct answer. 0.4. What is the ratio of the Aid flow from UN agencies (US$) of 2010 in Latin America(all income levels) to that in Sub-Saharan Africa (all income levels)?
Provide a succinct answer. 0.42. What is the ratio of the Aid flow from UN agencies (US$) in 2011 in Latin America(all income levels) to that in Sub-Saharan Africa (all income levels)?
Provide a short and direct response. 0.37. What is the ratio of the Aid flow from UN agencies (US$) in 2012 in Latin America(all income levels) to that in Sub-Saharan Africa (all income levels)?
Your answer should be compact. 0.41. What is the ratio of the Aid flow from UN agencies (US$) of 2009 in Latin America(all income levels) to that in Sub-Saharan Africa (developing only)?
Provide a succinct answer. 0.4. What is the ratio of the Aid flow from UN agencies (US$) in 2010 in Latin America(all income levels) to that in Sub-Saharan Africa (developing only)?
Provide a succinct answer. 0.42. What is the ratio of the Aid flow from UN agencies (US$) in 2011 in Latin America(all income levels) to that in Sub-Saharan Africa (developing only)?
Offer a terse response. 0.37. What is the ratio of the Aid flow from UN agencies (US$) of 2012 in Latin America(all income levels) to that in Sub-Saharan Africa (developing only)?
Provide a short and direct response. 0.42. What is the ratio of the Aid flow from UN agencies (US$) in 2009 in Latin America(developing only) to that in Low & middle income?
Offer a terse response. 0.1. What is the ratio of the Aid flow from UN agencies (US$) of 2010 in Latin America(developing only) to that in Low & middle income?
Ensure brevity in your answer.  0.1. What is the ratio of the Aid flow from UN agencies (US$) in 2011 in Latin America(developing only) to that in Low & middle income?
Give a very brief answer. 0.09. What is the ratio of the Aid flow from UN agencies (US$) in 2012 in Latin America(developing only) to that in Low & middle income?
Your answer should be very brief. 0.09. What is the ratio of the Aid flow from UN agencies (US$) in 2009 in Latin America(developing only) to that in Middle income?
Provide a short and direct response. 2. What is the ratio of the Aid flow from UN agencies (US$) of 2010 in Latin America(developing only) to that in Middle income?
Keep it short and to the point. 1.5. What is the ratio of the Aid flow from UN agencies (US$) of 2011 in Latin America(developing only) to that in Middle income?
Give a very brief answer. 0.43. What is the ratio of the Aid flow from UN agencies (US$) in 2012 in Latin America(developing only) to that in Middle income?
Make the answer very short. 0.45. What is the ratio of the Aid flow from UN agencies (US$) of 2009 in Latin America(developing only) to that in Sub-Saharan Africa (all income levels)?
Provide a short and direct response. 0.4. What is the ratio of the Aid flow from UN agencies (US$) in 2010 in Latin America(developing only) to that in Sub-Saharan Africa (all income levels)?
Offer a very short reply. 0.42. What is the ratio of the Aid flow from UN agencies (US$) of 2011 in Latin America(developing only) to that in Sub-Saharan Africa (all income levels)?
Make the answer very short. 0.37. What is the ratio of the Aid flow from UN agencies (US$) in 2012 in Latin America(developing only) to that in Sub-Saharan Africa (all income levels)?
Keep it short and to the point. 0.41. What is the ratio of the Aid flow from UN agencies (US$) of 2009 in Latin America(developing only) to that in Sub-Saharan Africa (developing only)?
Your response must be concise. 0.4. What is the ratio of the Aid flow from UN agencies (US$) in 2010 in Latin America(developing only) to that in Sub-Saharan Africa (developing only)?
Provide a succinct answer. 0.42. What is the ratio of the Aid flow from UN agencies (US$) in 2011 in Latin America(developing only) to that in Sub-Saharan Africa (developing only)?
Your answer should be compact. 0.37. What is the ratio of the Aid flow from UN agencies (US$) of 2012 in Latin America(developing only) to that in Sub-Saharan Africa (developing only)?
Your answer should be very brief. 0.42. What is the ratio of the Aid flow from UN agencies (US$) in 2009 in Low & middle income to that in Middle income?
Keep it short and to the point. 21. What is the ratio of the Aid flow from UN agencies (US$) in 2010 in Low & middle income to that in Middle income?
Your answer should be compact. 14.61. What is the ratio of the Aid flow from UN agencies (US$) in 2011 in Low & middle income to that in Middle income?
Keep it short and to the point. 5.02. What is the ratio of the Aid flow from UN agencies (US$) of 2012 in Low & middle income to that in Middle income?
Give a very brief answer. 4.76. What is the ratio of the Aid flow from UN agencies (US$) in 2009 in Low & middle income to that in Sub-Saharan Africa (all income levels)?
Provide a short and direct response. 4.22. What is the ratio of the Aid flow from UN agencies (US$) in 2010 in Low & middle income to that in Sub-Saharan Africa (all income levels)?
Your response must be concise. 4.08. What is the ratio of the Aid flow from UN agencies (US$) of 2011 in Low & middle income to that in Sub-Saharan Africa (all income levels)?
Your answer should be compact. 4.25. What is the ratio of the Aid flow from UN agencies (US$) in 2012 in Low & middle income to that in Sub-Saharan Africa (all income levels)?
Give a very brief answer. 4.38. What is the ratio of the Aid flow from UN agencies (US$) in 2009 in Low & middle income to that in Sub-Saharan Africa (developing only)?
Keep it short and to the point. 4.22. What is the ratio of the Aid flow from UN agencies (US$) in 2010 in Low & middle income to that in Sub-Saharan Africa (developing only)?
Offer a terse response. 4.08. What is the ratio of the Aid flow from UN agencies (US$) of 2011 in Low & middle income to that in Sub-Saharan Africa (developing only)?
Give a very brief answer. 4.28. What is the ratio of the Aid flow from UN agencies (US$) in 2012 in Low & middle income to that in Sub-Saharan Africa (developing only)?
Offer a terse response. 4.41. What is the ratio of the Aid flow from UN agencies (US$) in 2009 in Middle income to that in Sub-Saharan Africa (all income levels)?
Provide a succinct answer. 0.2. What is the ratio of the Aid flow from UN agencies (US$) of 2010 in Middle income to that in Sub-Saharan Africa (all income levels)?
Keep it short and to the point. 0.28. What is the ratio of the Aid flow from UN agencies (US$) in 2011 in Middle income to that in Sub-Saharan Africa (all income levels)?
Ensure brevity in your answer.  0.85. What is the ratio of the Aid flow from UN agencies (US$) in 2012 in Middle income to that in Sub-Saharan Africa (all income levels)?
Your response must be concise. 0.92. What is the ratio of the Aid flow from UN agencies (US$) of 2009 in Middle income to that in Sub-Saharan Africa (developing only)?
Offer a very short reply. 0.2. What is the ratio of the Aid flow from UN agencies (US$) in 2010 in Middle income to that in Sub-Saharan Africa (developing only)?
Give a very brief answer. 0.28. What is the ratio of the Aid flow from UN agencies (US$) in 2011 in Middle income to that in Sub-Saharan Africa (developing only)?
Your response must be concise. 0.85. What is the ratio of the Aid flow from UN agencies (US$) in 2012 in Middle income to that in Sub-Saharan Africa (developing only)?
Your answer should be very brief. 0.93. What is the ratio of the Aid flow from UN agencies (US$) of 2011 in Sub-Saharan Africa (all income levels) to that in Sub-Saharan Africa (developing only)?
Your answer should be compact. 1.01. What is the ratio of the Aid flow from UN agencies (US$) in 2012 in Sub-Saharan Africa (all income levels) to that in Sub-Saharan Africa (developing only)?
Your response must be concise. 1.01. What is the difference between the highest and the second highest Aid flow from UN agencies (US$) of 2009?
Your response must be concise. 3.33e+08. What is the difference between the highest and the second highest Aid flow from UN agencies (US$) of 2010?
Ensure brevity in your answer.  2.76e+08. What is the difference between the highest and the second highest Aid flow from UN agencies (US$) of 2011?
Your answer should be compact. 3.45e+08. What is the difference between the highest and the second highest Aid flow from UN agencies (US$) in 2012?
Your answer should be very brief. 3.06e+08. What is the difference between the highest and the lowest Aid flow from UN agencies (US$) in 2009?
Make the answer very short. 4.16e+08. What is the difference between the highest and the lowest Aid flow from UN agencies (US$) of 2010?
Your response must be concise. 3.41e+08. What is the difference between the highest and the lowest Aid flow from UN agencies (US$) of 2011?
Offer a terse response. 4.13e+08. What is the difference between the highest and the lowest Aid flow from UN agencies (US$) in 2012?
Your answer should be very brief. 3.59e+08. 